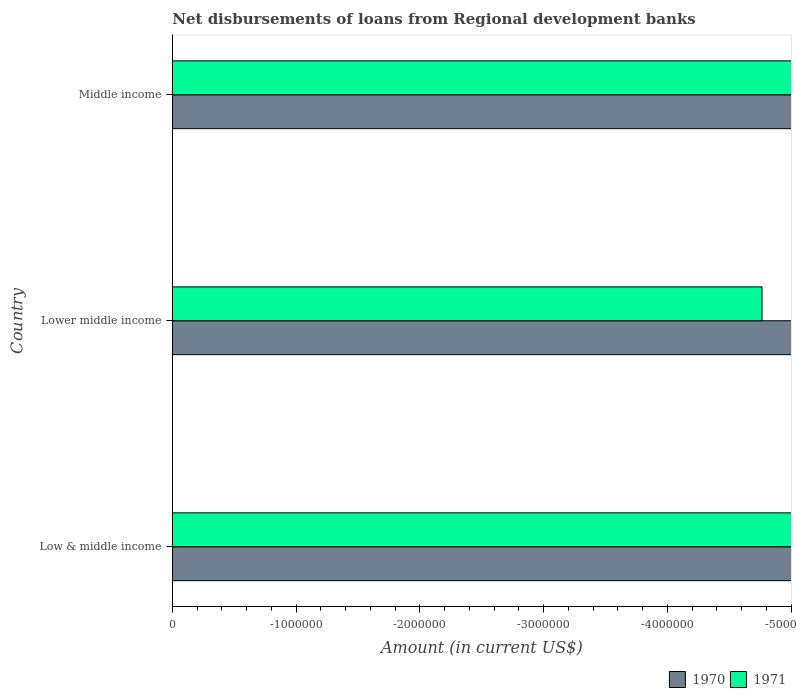How many different coloured bars are there?
Provide a succinct answer. 0. Are the number of bars per tick equal to the number of legend labels?
Make the answer very short. No. How many bars are there on the 2nd tick from the top?
Give a very brief answer. 0. How many bars are there on the 3rd tick from the bottom?
Provide a short and direct response. 0. What is the label of the 3rd group of bars from the top?
Your response must be concise. Low & middle income. In how many cases, is the number of bars for a given country not equal to the number of legend labels?
Offer a terse response. 3. What is the total amount of disbursements of loans from regional development banks in 1971 in the graph?
Provide a succinct answer. 0. What is the average amount of disbursements of loans from regional development banks in 1971 per country?
Your answer should be very brief. 0. In how many countries, is the amount of disbursements of loans from regional development banks in 1970 greater than the average amount of disbursements of loans from regional development banks in 1970 taken over all countries?
Your answer should be compact. 0. How many bars are there?
Offer a very short reply. 0. Are all the bars in the graph horizontal?
Provide a short and direct response. Yes. How many countries are there in the graph?
Offer a very short reply. 3. Are the values on the major ticks of X-axis written in scientific E-notation?
Your answer should be very brief. No. Does the graph contain any zero values?
Your answer should be very brief. Yes. Does the graph contain grids?
Your answer should be compact. No. How are the legend labels stacked?
Keep it short and to the point. Horizontal. What is the title of the graph?
Provide a short and direct response. Net disbursements of loans from Regional development banks. Does "1989" appear as one of the legend labels in the graph?
Your answer should be compact. No. What is the label or title of the X-axis?
Make the answer very short. Amount (in current US$). What is the label or title of the Y-axis?
Offer a very short reply. Country. What is the Amount (in current US$) in 1970 in Low & middle income?
Offer a very short reply. 0. What is the Amount (in current US$) in 1971 in Low & middle income?
Make the answer very short. 0. What is the Amount (in current US$) in 1970 in Lower middle income?
Give a very brief answer. 0. What is the Amount (in current US$) of 1970 in Middle income?
Your response must be concise. 0. What is the total Amount (in current US$) of 1971 in the graph?
Keep it short and to the point. 0. What is the average Amount (in current US$) in 1970 per country?
Keep it short and to the point. 0. What is the average Amount (in current US$) of 1971 per country?
Your answer should be very brief. 0. 